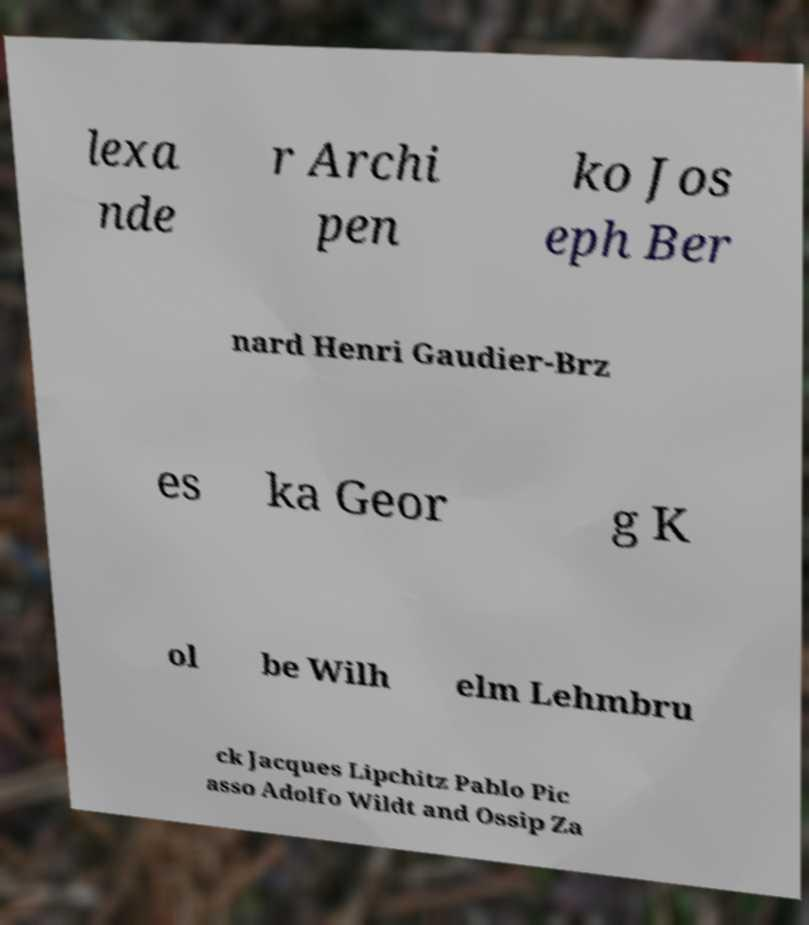Please read and relay the text visible in this image. What does it say? lexa nde r Archi pen ko Jos eph Ber nard Henri Gaudier-Brz es ka Geor g K ol be Wilh elm Lehmbru ck Jacques Lipchitz Pablo Pic asso Adolfo Wildt and Ossip Za 